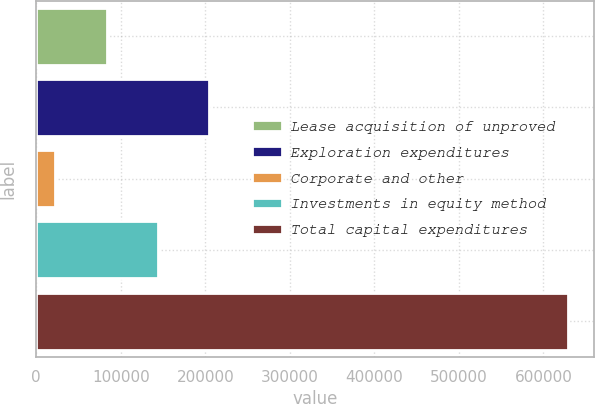<chart> <loc_0><loc_0><loc_500><loc_500><bar_chart><fcel>Lease acquisition of unproved<fcel>Exploration expenditures<fcel>Corporate and other<fcel>Investments in equity method<fcel>Total capital expenditures<nl><fcel>83263.7<fcel>204513<fcel>22639<fcel>143888<fcel>628886<nl></chart> 